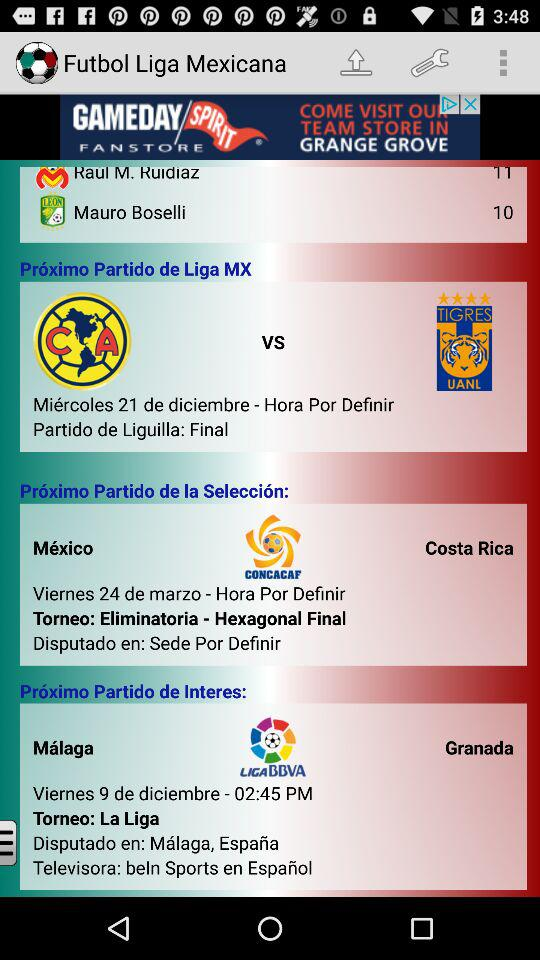How many more goals does Raul M. Ruidiaz have than Mauro Boselli?
Answer the question using a single word or phrase. 1 